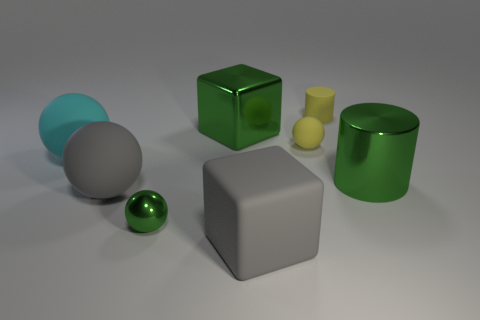How many other objects are the same shape as the cyan object? 3 